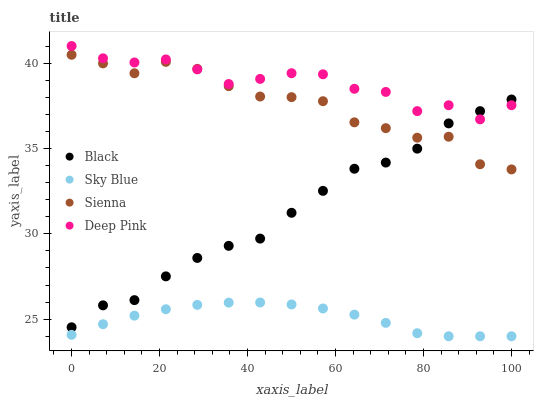Does Sky Blue have the minimum area under the curve?
Answer yes or no. Yes. Does Deep Pink have the maximum area under the curve?
Answer yes or no. Yes. Does Deep Pink have the minimum area under the curve?
Answer yes or no. No. Does Sky Blue have the maximum area under the curve?
Answer yes or no. No. Is Sky Blue the smoothest?
Answer yes or no. Yes. Is Deep Pink the roughest?
Answer yes or no. Yes. Is Deep Pink the smoothest?
Answer yes or no. No. Is Sky Blue the roughest?
Answer yes or no. No. Does Sky Blue have the lowest value?
Answer yes or no. Yes. Does Deep Pink have the lowest value?
Answer yes or no. No. Does Deep Pink have the highest value?
Answer yes or no. Yes. Does Sky Blue have the highest value?
Answer yes or no. No. Is Sky Blue less than Deep Pink?
Answer yes or no. Yes. Is Deep Pink greater than Sky Blue?
Answer yes or no. Yes. Does Sienna intersect Deep Pink?
Answer yes or no. Yes. Is Sienna less than Deep Pink?
Answer yes or no. No. Is Sienna greater than Deep Pink?
Answer yes or no. No. Does Sky Blue intersect Deep Pink?
Answer yes or no. No. 